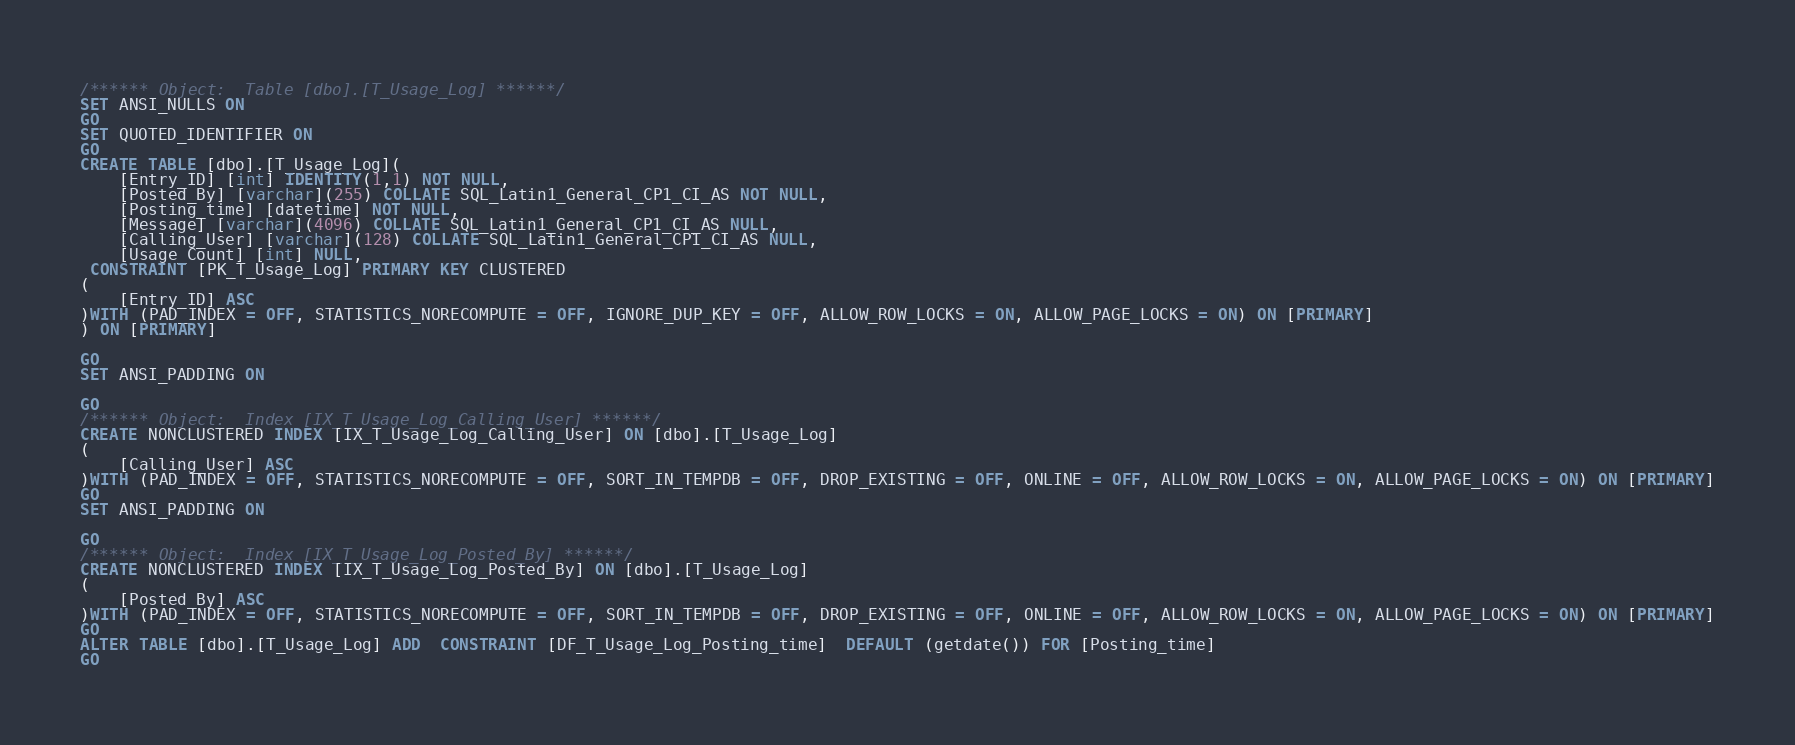Convert code to text. <code><loc_0><loc_0><loc_500><loc_500><_SQL_>/****** Object:  Table [dbo].[T_Usage_Log] ******/
SET ANSI_NULLS ON
GO
SET QUOTED_IDENTIFIER ON
GO
CREATE TABLE [dbo].[T_Usage_Log](
	[Entry_ID] [int] IDENTITY(1,1) NOT NULL,
	[Posted_By] [varchar](255) COLLATE SQL_Latin1_General_CP1_CI_AS NOT NULL,
	[Posting_time] [datetime] NOT NULL,
	[Message] [varchar](4096) COLLATE SQL_Latin1_General_CP1_CI_AS NULL,
	[Calling_User] [varchar](128) COLLATE SQL_Latin1_General_CP1_CI_AS NULL,
	[Usage_Count] [int] NULL,
 CONSTRAINT [PK_T_Usage_Log] PRIMARY KEY CLUSTERED 
(
	[Entry_ID] ASC
)WITH (PAD_INDEX = OFF, STATISTICS_NORECOMPUTE = OFF, IGNORE_DUP_KEY = OFF, ALLOW_ROW_LOCKS = ON, ALLOW_PAGE_LOCKS = ON) ON [PRIMARY]
) ON [PRIMARY]

GO
SET ANSI_PADDING ON

GO
/****** Object:  Index [IX_T_Usage_Log_Calling_User] ******/
CREATE NONCLUSTERED INDEX [IX_T_Usage_Log_Calling_User] ON [dbo].[T_Usage_Log]
(
	[Calling_User] ASC
)WITH (PAD_INDEX = OFF, STATISTICS_NORECOMPUTE = OFF, SORT_IN_TEMPDB = OFF, DROP_EXISTING = OFF, ONLINE = OFF, ALLOW_ROW_LOCKS = ON, ALLOW_PAGE_LOCKS = ON) ON [PRIMARY]
GO
SET ANSI_PADDING ON

GO
/****** Object:  Index [IX_T_Usage_Log_Posted_By] ******/
CREATE NONCLUSTERED INDEX [IX_T_Usage_Log_Posted_By] ON [dbo].[T_Usage_Log]
(
	[Posted_By] ASC
)WITH (PAD_INDEX = OFF, STATISTICS_NORECOMPUTE = OFF, SORT_IN_TEMPDB = OFF, DROP_EXISTING = OFF, ONLINE = OFF, ALLOW_ROW_LOCKS = ON, ALLOW_PAGE_LOCKS = ON) ON [PRIMARY]
GO
ALTER TABLE [dbo].[T_Usage_Log] ADD  CONSTRAINT [DF_T_Usage_Log_Posting_time]  DEFAULT (getdate()) FOR [Posting_time]
GO
</code> 